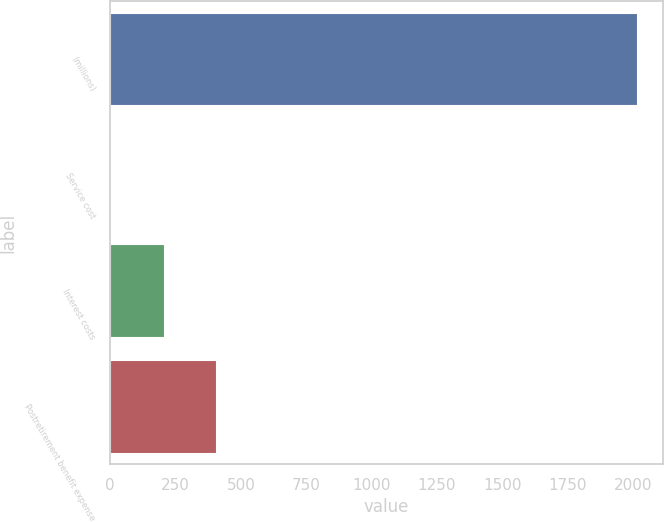Convert chart to OTSL. <chart><loc_0><loc_0><loc_500><loc_500><bar_chart><fcel>(millions)<fcel>Service cost<fcel>Interest costs<fcel>Postretirement benefit expense<nl><fcel>2015<fcel>3.1<fcel>204.29<fcel>405.48<nl></chart> 